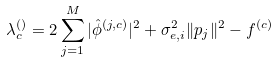Convert formula to latex. <formula><loc_0><loc_0><loc_500><loc_500>\lambda _ { c } ^ { \left ( \right ) } = 2 \sum _ { j = 1 } ^ { M } | \hat { \phi } ^ { \left ( j , c \right ) } | ^ { 2 } + \sigma _ { e , i } ^ { 2 } \| p _ { j } \| ^ { 2 } - f ^ { \left ( c \right ) }</formula> 